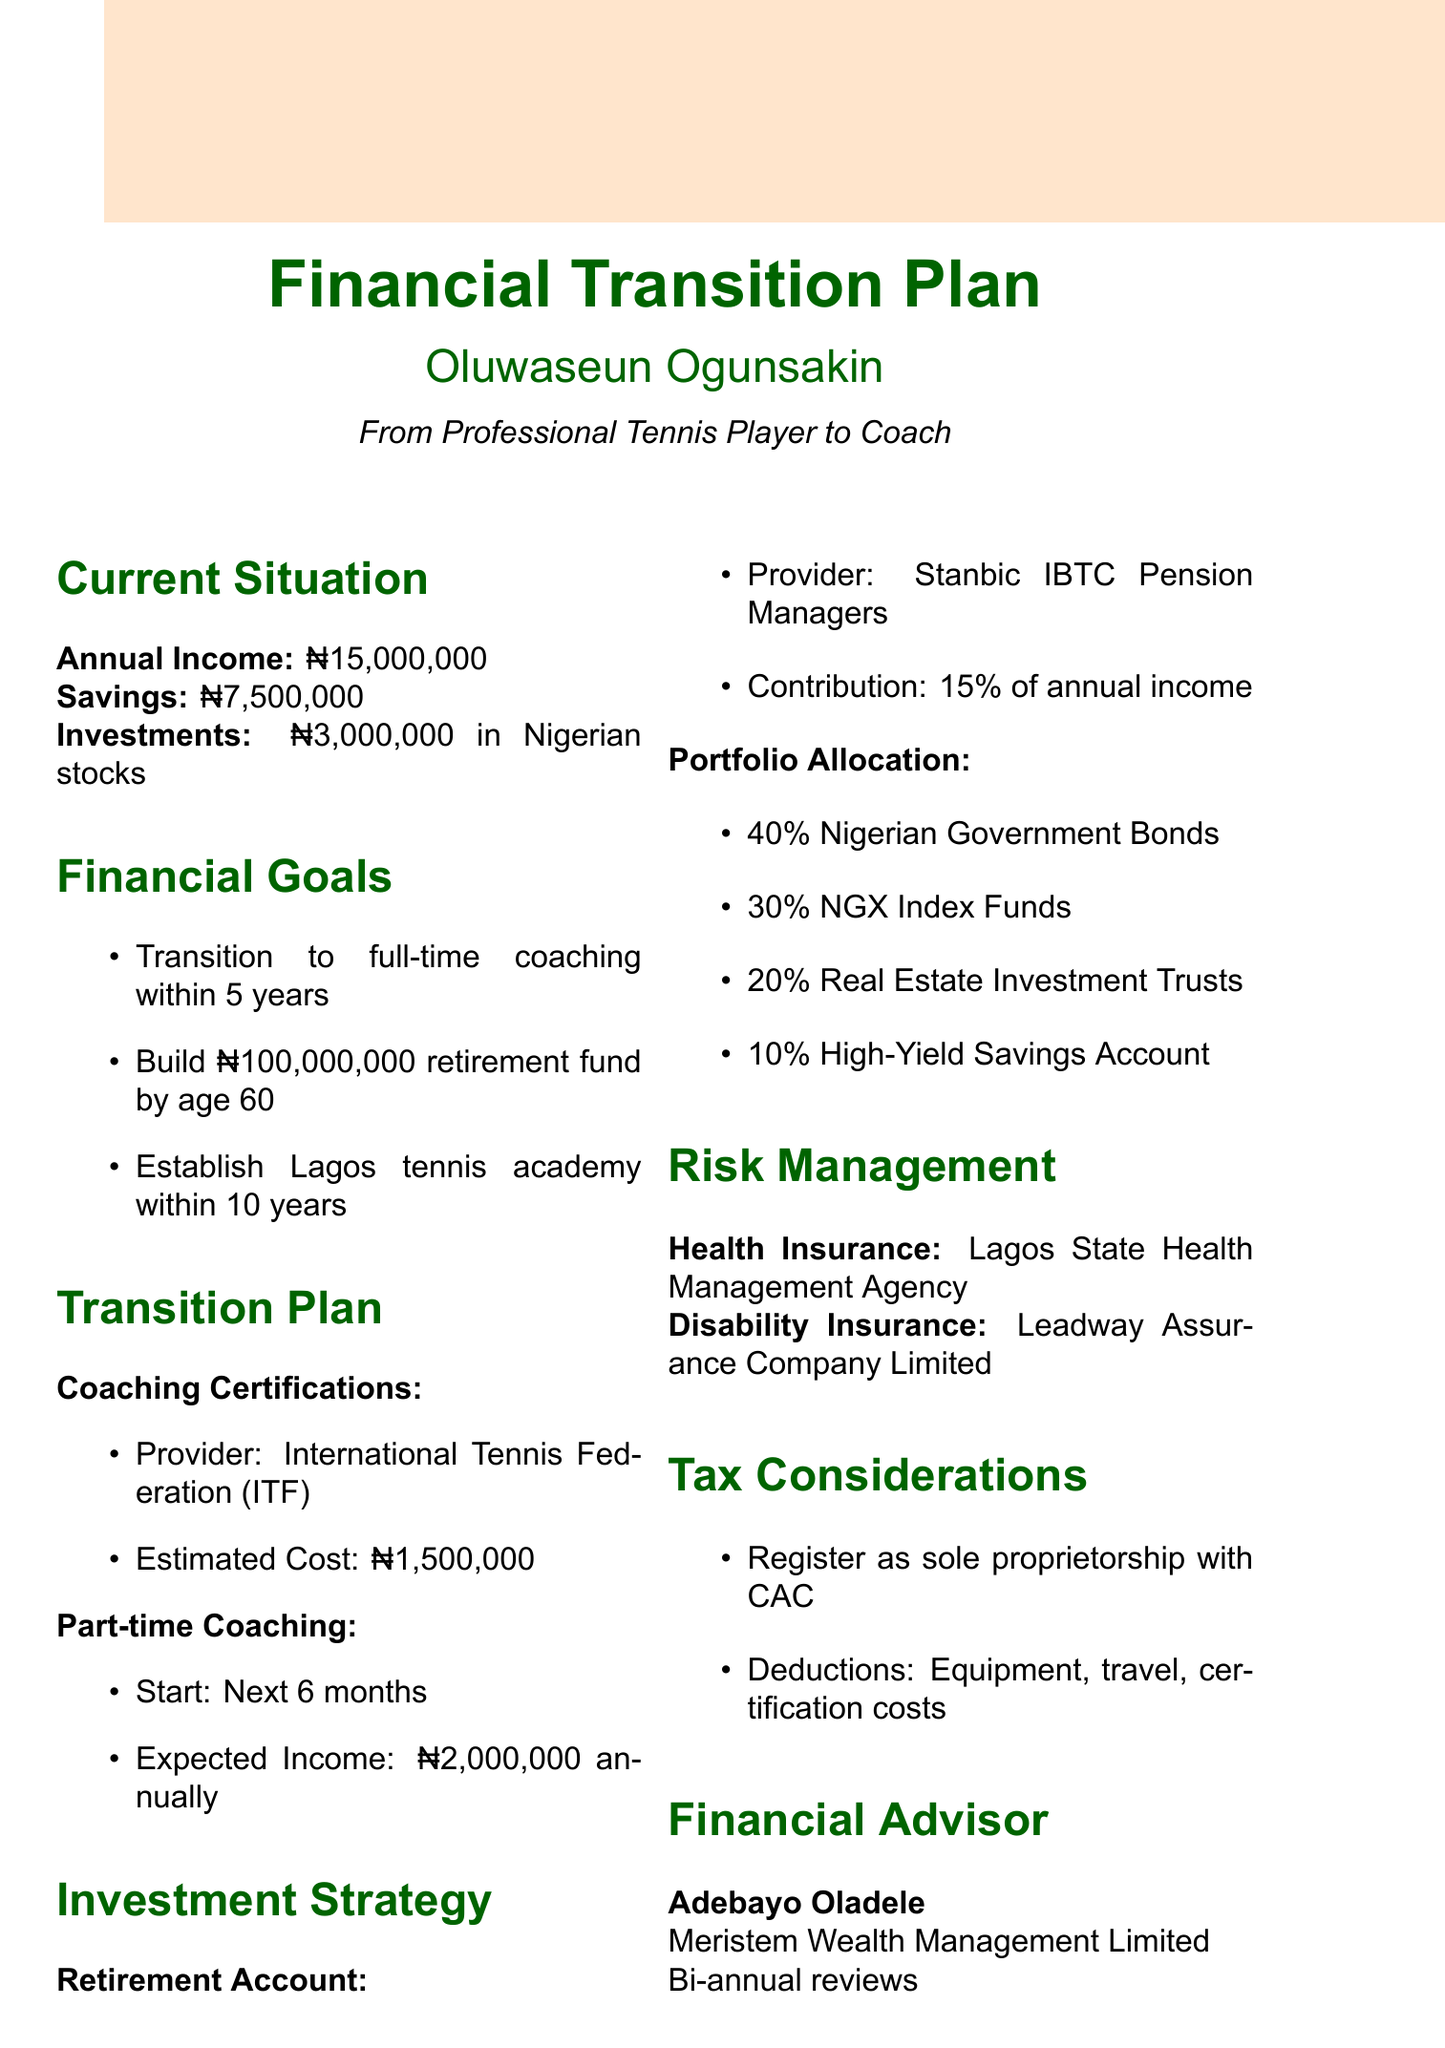What is the duration for transitioning to full-time coaching? The document states the goal is to transition within 5 years.
Answer: 5 years What is the estimated cost of coaching certifications? The estimated cost for coaching certifications from the International Tennis Federation is detailed in the transition plan.
Answer: ₦1,500,000 What percentage of annual income will be contributed to the retirement account? The investment strategy specifies that 15% of the annual income will be contributed to the retirement account.
Answer: 15% What is the expected income from part-time coaching? The expected income from part-time coaching mentioned in the transition plan is stated clearly.
Answer: ₦2,000,000 annually What is the target amount for the retirement fund by age 60? The document lists the goal to build a retirement fund of ₦100,000,000.
Answer: ₦100,000,000 Which company provides health insurance? The document specifies the health insurance provider as Lagos State Health Management Agency.
Answer: Lagos State Health Management Agency What is the structure to register for tax considerations? The tax considerations section indicates that the structure will be a sole proprietorship.
Answer: Sole proprietorship How often will the financial advisor conduct reviews? The frequency of reviews with the financial advisor is mentioned in the document.
Answer: Bi-annual 